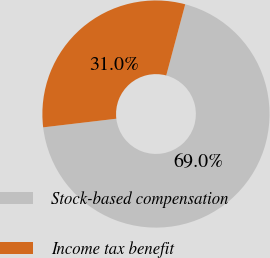<chart> <loc_0><loc_0><loc_500><loc_500><pie_chart><fcel>Stock-based compensation<fcel>Income tax benefit<nl><fcel>68.98%<fcel>31.02%<nl></chart> 